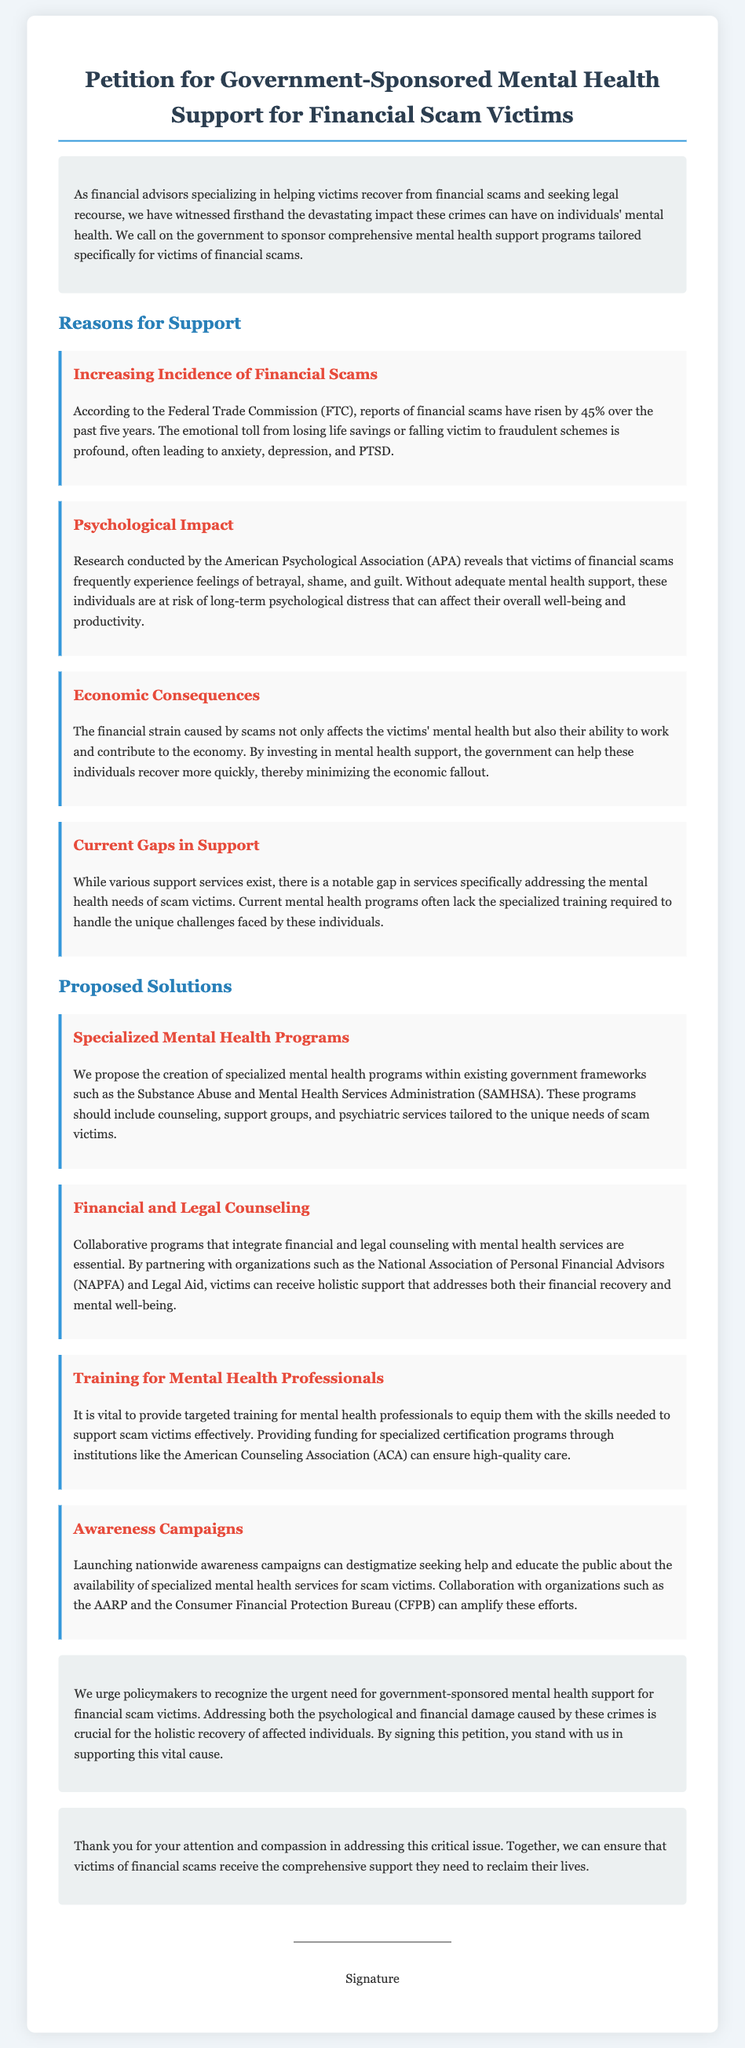What is the main objective of the petition? The main objective is to call on the government to sponsor comprehensive mental health support programs specifically for victims of financial scams.
Answer: Comprehensive mental health support How much have reports of financial scams increased over the past five years? The document states that reports of financial scams have risen by 45% over the past five years, according to the Federal Trade Commission (FTC).
Answer: 45% Which organization conducted research on the psychological impact of financial scams? The document mentions that research on the psychological impact was conducted by the American Psychological Association (APA).
Answer: American Psychological Association What is one proposed solution to support scam victims? The document proposes the creation of specialized mental health programs tailored to the unique needs of scam victims as one solution.
Answer: Specialized mental health programs What are the two types of counseling integrated with mental health services in proposed solutions? The integrated counseling types mentioned in the document are financial counseling and legal counseling.
Answer: Financial and legal counseling Which government agency is suggested for collaboration to create specialized mental health programs? The suggested agency for collaboration to create specialized mental health programs is the Substance Abuse and Mental Health Services Administration (SAMHSA).
Answer: Substance Abuse and Mental Health Services Administration What is a goal of awareness campaigns proposed in the petition? The goal of launching nationwide awareness campaigns is to destigmatize seeking help for scam victims.
Answer: Destigmatize seeking help Who can amplify awareness efforts according to the document? The document mentions that organizations such as the AARP and the Consumer Financial Protection Bureau (CFPB) can amplify awareness efforts.
Answer: AARP and Consumer Financial Protection Bureau 